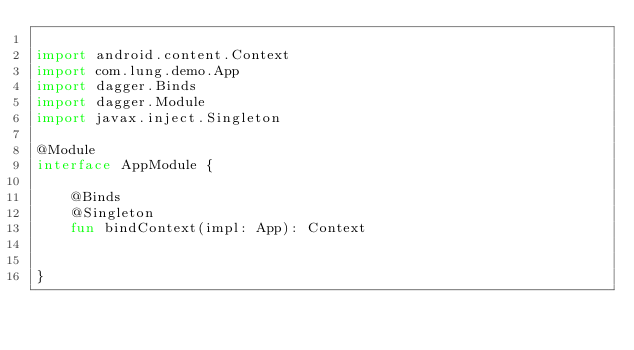<code> <loc_0><loc_0><loc_500><loc_500><_Kotlin_>
import android.content.Context
import com.lung.demo.App
import dagger.Binds
import dagger.Module
import javax.inject.Singleton

@Module
interface AppModule {

    @Binds
    @Singleton
    fun bindContext(impl: App): Context


}

</code> 